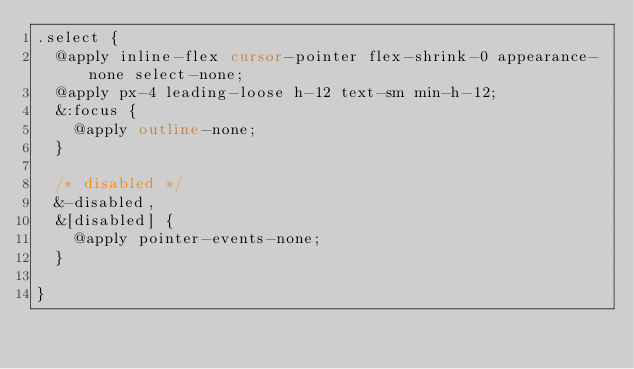<code> <loc_0><loc_0><loc_500><loc_500><_CSS_>.select {
  @apply inline-flex cursor-pointer flex-shrink-0 appearance-none select-none;
  @apply px-4 leading-loose h-12 text-sm min-h-12;
  &:focus {
    @apply outline-none;
  }

  /* disabled */
  &-disabled,
  &[disabled] {
    @apply pointer-events-none;
  }

}</code> 